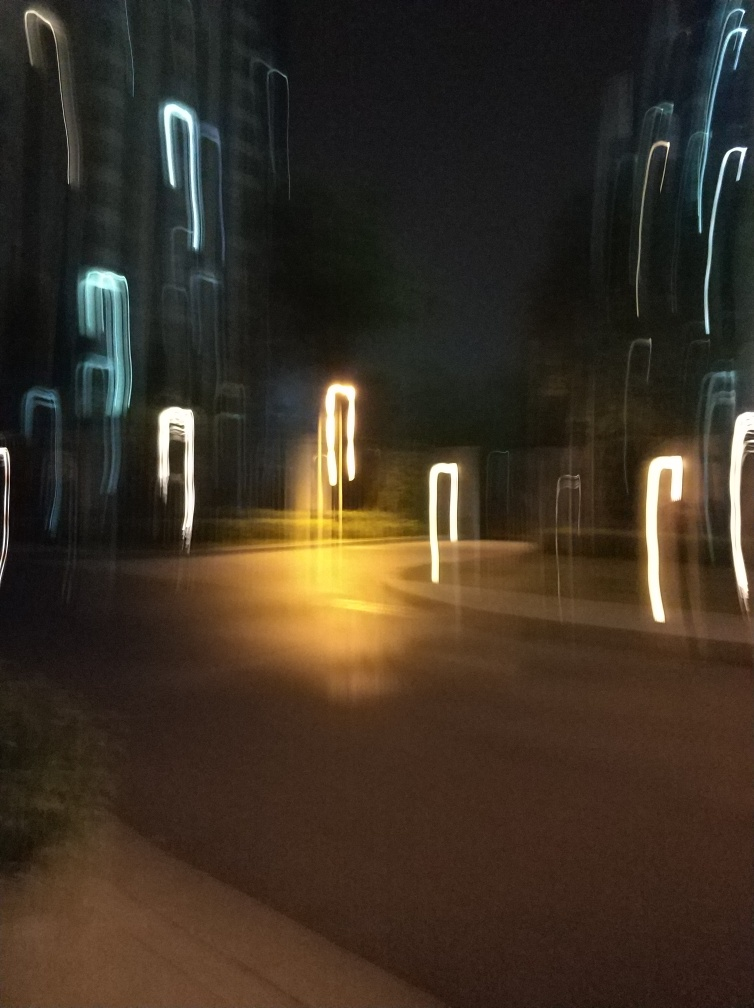What might be the cause of the blurred lines in this image? The blurred lines are likely caused by a long exposure time combined with camera movement. This technique captures the trajectory of light sources, creating streaks or lines that represent where the lights traveled during the time the camera's shutter was open. Is there a specific term for this kind of photography? Yes, this type of photography is typically referred to as 'motion blur' photography. It can be intentional, to convey motion, or accidental, from moving the camera during a longer exposure. 